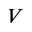Convert formula to latex. <formula><loc_0><loc_0><loc_500><loc_500>V</formula> 